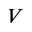Convert formula to latex. <formula><loc_0><loc_0><loc_500><loc_500>V</formula> 